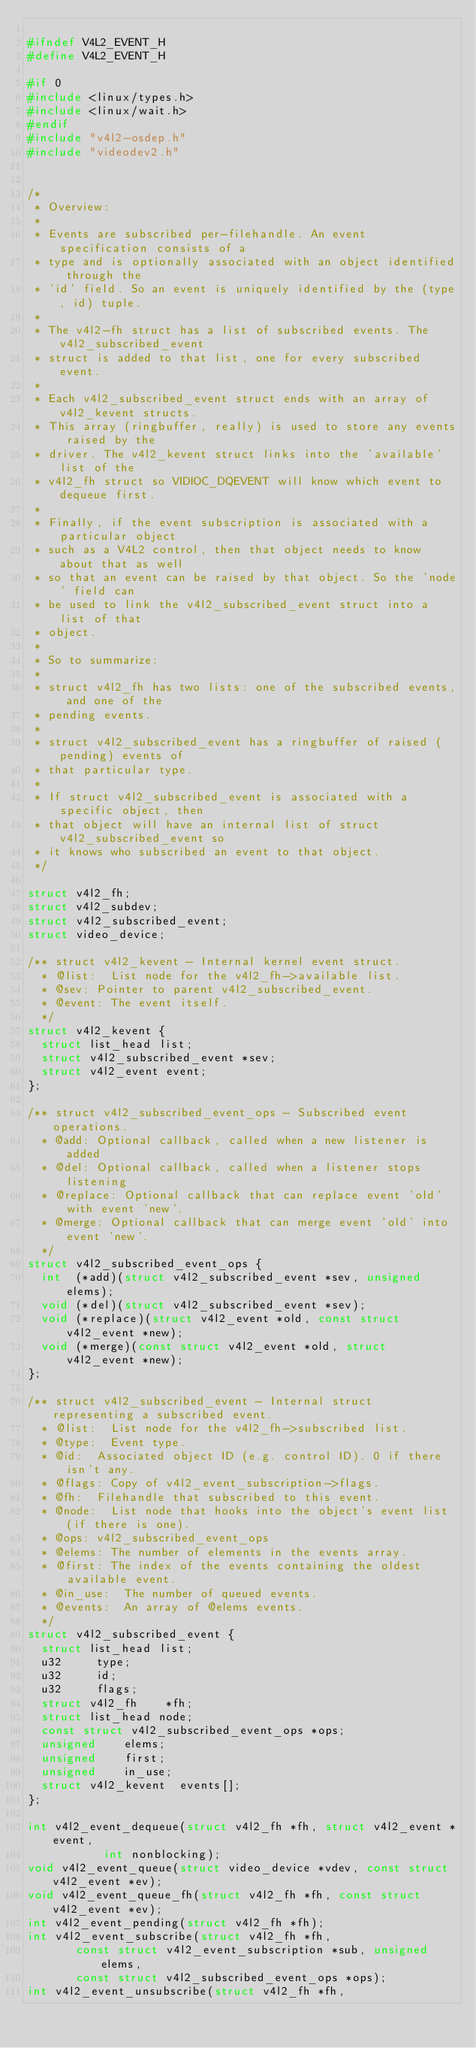<code> <loc_0><loc_0><loc_500><loc_500><_C_>
#ifndef V4L2_EVENT_H
#define V4L2_EVENT_H

#if 0
#include <linux/types.h>
#include <linux/wait.h>
#endif
#include "v4l2-osdep.h"
#include "videodev2.h"


/*
 * Overview:
 *
 * Events are subscribed per-filehandle. An event specification consists of a
 * type and is optionally associated with an object identified through the
 * 'id' field. So an event is uniquely identified by the (type, id) tuple.
 *
 * The v4l2-fh struct has a list of subscribed events. The v4l2_subscribed_event
 * struct is added to that list, one for every subscribed event.
 *
 * Each v4l2_subscribed_event struct ends with an array of v4l2_kevent structs.
 * This array (ringbuffer, really) is used to store any events raised by the
 * driver. The v4l2_kevent struct links into the 'available' list of the
 * v4l2_fh struct so VIDIOC_DQEVENT will know which event to dequeue first.
 *
 * Finally, if the event subscription is associated with a particular object
 * such as a V4L2 control, then that object needs to know about that as well
 * so that an event can be raised by that object. So the 'node' field can
 * be used to link the v4l2_subscribed_event struct into a list of that
 * object.
 *
 * So to summarize:
 *
 * struct v4l2_fh has two lists: one of the subscribed events, and one of the
 * pending events.
 *
 * struct v4l2_subscribed_event has a ringbuffer of raised (pending) events of
 * that particular type.
 *
 * If struct v4l2_subscribed_event is associated with a specific object, then
 * that object will have an internal list of struct v4l2_subscribed_event so
 * it knows who subscribed an event to that object.
 */

struct v4l2_fh;
struct v4l2_subdev;
struct v4l2_subscribed_event;
struct video_device;

/** struct v4l2_kevent - Internal kernel event struct.
  * @list:	List node for the v4l2_fh->available list.
  * @sev:	Pointer to parent v4l2_subscribed_event.
  * @event:	The event itself.
  */
struct v4l2_kevent {
	struct list_head list;
	struct v4l2_subscribed_event *sev;
	struct v4l2_event	event;
};

/** struct v4l2_subscribed_event_ops - Subscribed event operations.
  * @add:	Optional callback, called when a new listener is added
  * @del:	Optional callback, called when a listener stops listening
  * @replace:	Optional callback that can replace event 'old' with event 'new'.
  * @merge:	Optional callback that can merge event 'old' into event 'new'.
  */
struct v4l2_subscribed_event_ops {
	int  (*add)(struct v4l2_subscribed_event *sev, unsigned elems);
	void (*del)(struct v4l2_subscribed_event *sev);
	void (*replace)(struct v4l2_event *old, const struct v4l2_event *new);
	void (*merge)(const struct v4l2_event *old, struct v4l2_event *new);
};

/** struct v4l2_subscribed_event - Internal struct representing a subscribed event.
  * @list:	List node for the v4l2_fh->subscribed list.
  * @type:	Event type.
  * @id:	Associated object ID (e.g. control ID). 0 if there isn't any.
  * @flags:	Copy of v4l2_event_subscription->flags.
  * @fh:	Filehandle that subscribed to this event.
  * @node:	List node that hooks into the object's event list (if there is one).
  * @ops:	v4l2_subscribed_event_ops
  * @elems:	The number of elements in the events array.
  * @first:	The index of the events containing the oldest available event.
  * @in_use:	The number of queued events.
  * @events:	An array of @elems events.
  */
struct v4l2_subscribed_event {
	struct list_head list;
	u32			type;
	u32			id;
	u32			flags;
	struct v4l2_fh		*fh;
	struct list_head node;
	const struct v4l2_subscribed_event_ops *ops;
	unsigned		elems;
	unsigned		first;
	unsigned		in_use;
	struct v4l2_kevent	events[];
};

int v4l2_event_dequeue(struct v4l2_fh *fh, struct v4l2_event *event,
		       int nonblocking);
void v4l2_event_queue(struct video_device *vdev, const struct v4l2_event *ev);
void v4l2_event_queue_fh(struct v4l2_fh *fh, const struct v4l2_event *ev);
int v4l2_event_pending(struct v4l2_fh *fh);
int v4l2_event_subscribe(struct v4l2_fh *fh,
			 const struct v4l2_event_subscription *sub, unsigned elems,
			 const struct v4l2_subscribed_event_ops *ops);
int v4l2_event_unsubscribe(struct v4l2_fh *fh,</code> 